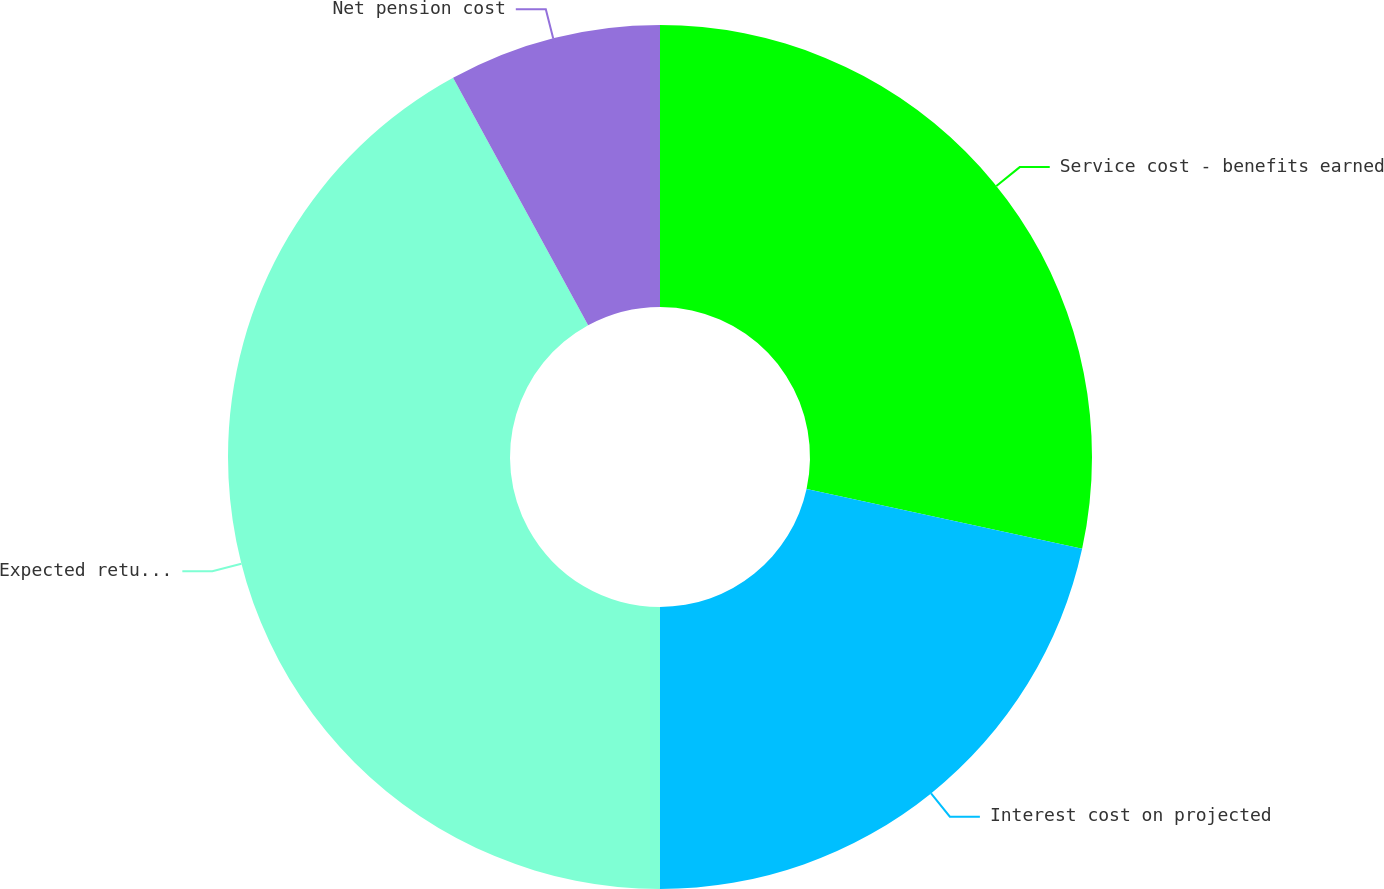Convert chart to OTSL. <chart><loc_0><loc_0><loc_500><loc_500><pie_chart><fcel>Service cost - benefits earned<fcel>Interest cost on projected<fcel>Expected return on plan assets<fcel>Net pension cost<nl><fcel>28.41%<fcel>21.59%<fcel>42.05%<fcel>7.95%<nl></chart> 